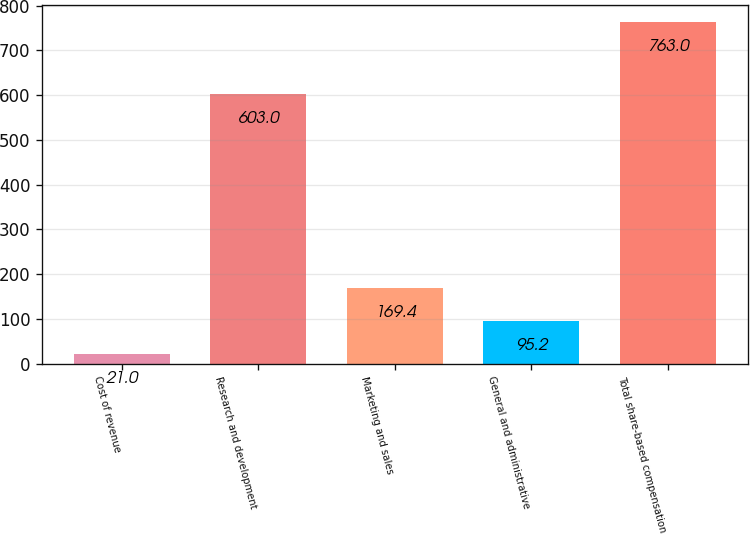<chart> <loc_0><loc_0><loc_500><loc_500><bar_chart><fcel>Cost of revenue<fcel>Research and development<fcel>Marketing and sales<fcel>General and administrative<fcel>Total share-based compensation<nl><fcel>21<fcel>603<fcel>169.4<fcel>95.2<fcel>763<nl></chart> 